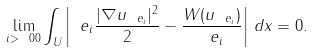Convert formula to latex. <formula><loc_0><loc_0><loc_500><loc_500>\lim _ { i > \ 0 0 } \int _ { U } \left | \ e _ { i } \frac { | \nabla u _ { \ e _ { i } } | ^ { 2 } } { 2 } - \frac { W ( u _ { \ e _ { i } } ) } { \ e _ { i } } \right | \, d { x } = 0 .</formula> 